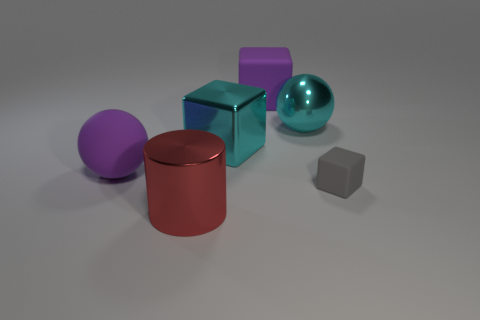Add 2 cyan objects. How many objects exist? 8 Subtract all cylinders. How many objects are left? 5 Subtract 0 cyan cylinders. How many objects are left? 6 Subtract all cubes. Subtract all small blue metal spheres. How many objects are left? 3 Add 2 gray cubes. How many gray cubes are left? 3 Add 6 big brown rubber cylinders. How many big brown rubber cylinders exist? 6 